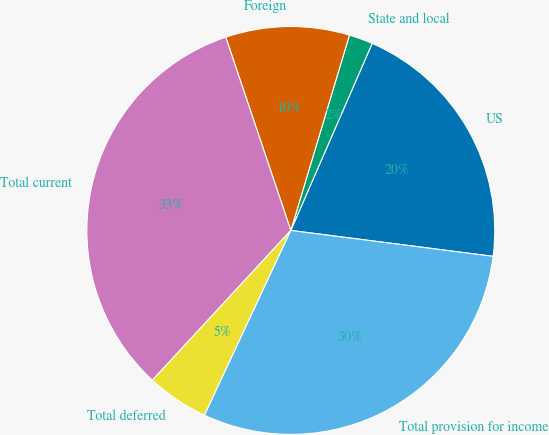Convert chart to OTSL. <chart><loc_0><loc_0><loc_500><loc_500><pie_chart><fcel>US<fcel>State and local<fcel>Foreign<fcel>Total current<fcel>Total deferred<fcel>Total provision for income<nl><fcel>20.5%<fcel>1.89%<fcel>9.81%<fcel>32.96%<fcel>4.92%<fcel>29.93%<nl></chart> 